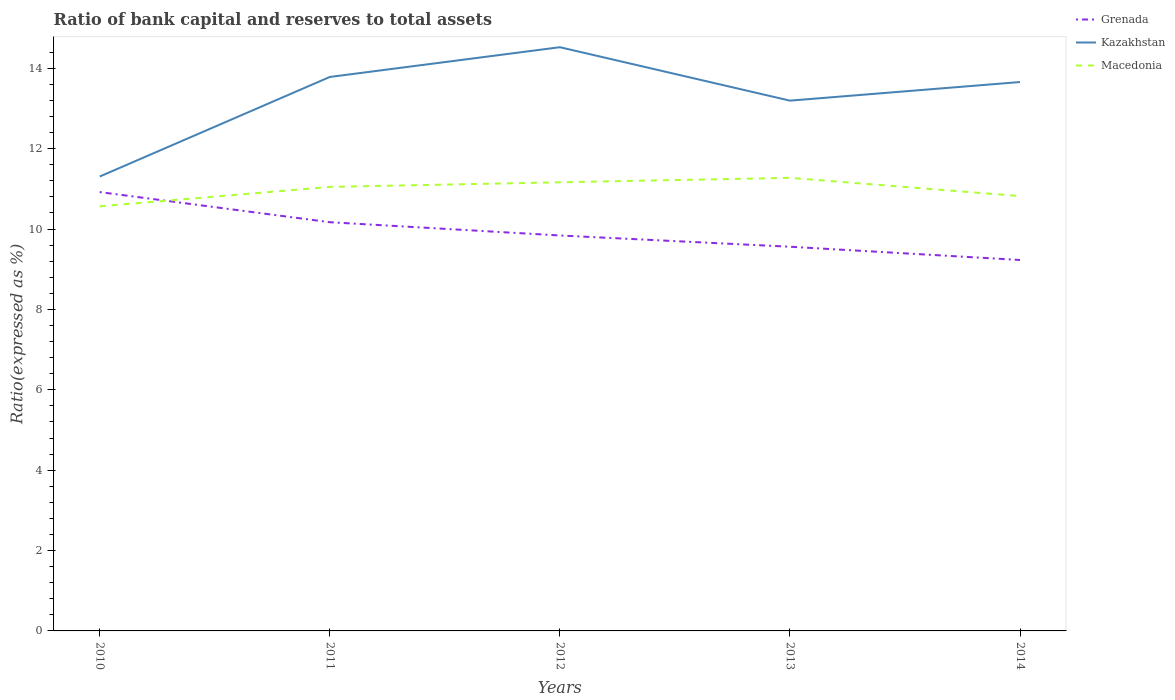How many different coloured lines are there?
Ensure brevity in your answer.  3. Does the line corresponding to Macedonia intersect with the line corresponding to Grenada?
Offer a very short reply. Yes. Is the number of lines equal to the number of legend labels?
Your answer should be very brief. Yes. Across all years, what is the maximum ratio of bank capital and reserves to total assets in Grenada?
Make the answer very short. 9.23. In which year was the ratio of bank capital and reserves to total assets in Macedonia maximum?
Offer a terse response. 2010. What is the total ratio of bank capital and reserves to total assets in Macedonia in the graph?
Offer a very short reply. 0.23. What is the difference between the highest and the second highest ratio of bank capital and reserves to total assets in Grenada?
Ensure brevity in your answer.  1.69. How many lines are there?
Your answer should be compact. 3. Does the graph contain any zero values?
Offer a terse response. No. Does the graph contain grids?
Ensure brevity in your answer.  No. What is the title of the graph?
Provide a short and direct response. Ratio of bank capital and reserves to total assets. Does "Latin America(developing only)" appear as one of the legend labels in the graph?
Give a very brief answer. No. What is the label or title of the Y-axis?
Your response must be concise. Ratio(expressed as %). What is the Ratio(expressed as %) of Grenada in 2010?
Your answer should be compact. 10.92. What is the Ratio(expressed as %) in Kazakhstan in 2010?
Provide a succinct answer. 11.31. What is the Ratio(expressed as %) of Macedonia in 2010?
Your answer should be very brief. 10.57. What is the Ratio(expressed as %) of Grenada in 2011?
Give a very brief answer. 10.17. What is the Ratio(expressed as %) of Kazakhstan in 2011?
Keep it short and to the point. 13.78. What is the Ratio(expressed as %) in Macedonia in 2011?
Give a very brief answer. 11.05. What is the Ratio(expressed as %) in Grenada in 2012?
Provide a succinct answer. 9.84. What is the Ratio(expressed as %) of Kazakhstan in 2012?
Ensure brevity in your answer.  14.52. What is the Ratio(expressed as %) in Macedonia in 2012?
Offer a terse response. 11.16. What is the Ratio(expressed as %) of Grenada in 2013?
Your response must be concise. 9.56. What is the Ratio(expressed as %) in Kazakhstan in 2013?
Offer a terse response. 13.2. What is the Ratio(expressed as %) of Macedonia in 2013?
Offer a terse response. 11.27. What is the Ratio(expressed as %) in Grenada in 2014?
Make the answer very short. 9.23. What is the Ratio(expressed as %) of Kazakhstan in 2014?
Make the answer very short. 13.66. What is the Ratio(expressed as %) of Macedonia in 2014?
Provide a short and direct response. 10.82. Across all years, what is the maximum Ratio(expressed as %) in Grenada?
Offer a terse response. 10.92. Across all years, what is the maximum Ratio(expressed as %) of Kazakhstan?
Make the answer very short. 14.52. Across all years, what is the maximum Ratio(expressed as %) in Macedonia?
Your answer should be very brief. 11.27. Across all years, what is the minimum Ratio(expressed as %) of Grenada?
Ensure brevity in your answer.  9.23. Across all years, what is the minimum Ratio(expressed as %) in Kazakhstan?
Ensure brevity in your answer.  11.31. Across all years, what is the minimum Ratio(expressed as %) in Macedonia?
Offer a terse response. 10.57. What is the total Ratio(expressed as %) in Grenada in the graph?
Your response must be concise. 49.72. What is the total Ratio(expressed as %) of Kazakhstan in the graph?
Your answer should be compact. 66.47. What is the total Ratio(expressed as %) in Macedonia in the graph?
Provide a short and direct response. 54.87. What is the difference between the Ratio(expressed as %) of Grenada in 2010 and that in 2011?
Provide a succinct answer. 0.75. What is the difference between the Ratio(expressed as %) in Kazakhstan in 2010 and that in 2011?
Give a very brief answer. -2.48. What is the difference between the Ratio(expressed as %) of Macedonia in 2010 and that in 2011?
Offer a terse response. -0.48. What is the difference between the Ratio(expressed as %) in Kazakhstan in 2010 and that in 2012?
Your answer should be compact. -3.22. What is the difference between the Ratio(expressed as %) of Macedonia in 2010 and that in 2012?
Ensure brevity in your answer.  -0.6. What is the difference between the Ratio(expressed as %) in Grenada in 2010 and that in 2013?
Your response must be concise. 1.36. What is the difference between the Ratio(expressed as %) in Kazakhstan in 2010 and that in 2013?
Make the answer very short. -1.89. What is the difference between the Ratio(expressed as %) of Macedonia in 2010 and that in 2013?
Your answer should be compact. -0.71. What is the difference between the Ratio(expressed as %) of Grenada in 2010 and that in 2014?
Provide a short and direct response. 1.69. What is the difference between the Ratio(expressed as %) in Kazakhstan in 2010 and that in 2014?
Give a very brief answer. -2.35. What is the difference between the Ratio(expressed as %) in Macedonia in 2010 and that in 2014?
Your answer should be very brief. -0.25. What is the difference between the Ratio(expressed as %) in Grenada in 2011 and that in 2012?
Provide a succinct answer. 0.33. What is the difference between the Ratio(expressed as %) of Kazakhstan in 2011 and that in 2012?
Ensure brevity in your answer.  -0.74. What is the difference between the Ratio(expressed as %) in Macedonia in 2011 and that in 2012?
Ensure brevity in your answer.  -0.12. What is the difference between the Ratio(expressed as %) of Grenada in 2011 and that in 2013?
Provide a succinct answer. 0.61. What is the difference between the Ratio(expressed as %) of Kazakhstan in 2011 and that in 2013?
Your answer should be compact. 0.59. What is the difference between the Ratio(expressed as %) in Macedonia in 2011 and that in 2013?
Your answer should be very brief. -0.23. What is the difference between the Ratio(expressed as %) of Grenada in 2011 and that in 2014?
Your answer should be compact. 0.94. What is the difference between the Ratio(expressed as %) in Kazakhstan in 2011 and that in 2014?
Ensure brevity in your answer.  0.13. What is the difference between the Ratio(expressed as %) of Macedonia in 2011 and that in 2014?
Make the answer very short. 0.23. What is the difference between the Ratio(expressed as %) in Grenada in 2012 and that in 2013?
Offer a terse response. 0.28. What is the difference between the Ratio(expressed as %) of Kazakhstan in 2012 and that in 2013?
Provide a succinct answer. 1.33. What is the difference between the Ratio(expressed as %) of Macedonia in 2012 and that in 2013?
Offer a terse response. -0.11. What is the difference between the Ratio(expressed as %) of Grenada in 2012 and that in 2014?
Your answer should be very brief. 0.61. What is the difference between the Ratio(expressed as %) of Kazakhstan in 2012 and that in 2014?
Your answer should be compact. 0.87. What is the difference between the Ratio(expressed as %) in Macedonia in 2012 and that in 2014?
Your answer should be very brief. 0.34. What is the difference between the Ratio(expressed as %) in Grenada in 2013 and that in 2014?
Offer a very short reply. 0.33. What is the difference between the Ratio(expressed as %) in Kazakhstan in 2013 and that in 2014?
Offer a very short reply. -0.46. What is the difference between the Ratio(expressed as %) in Macedonia in 2013 and that in 2014?
Provide a short and direct response. 0.45. What is the difference between the Ratio(expressed as %) in Grenada in 2010 and the Ratio(expressed as %) in Kazakhstan in 2011?
Provide a succinct answer. -2.86. What is the difference between the Ratio(expressed as %) in Grenada in 2010 and the Ratio(expressed as %) in Macedonia in 2011?
Provide a succinct answer. -0.13. What is the difference between the Ratio(expressed as %) in Kazakhstan in 2010 and the Ratio(expressed as %) in Macedonia in 2011?
Provide a short and direct response. 0.26. What is the difference between the Ratio(expressed as %) in Grenada in 2010 and the Ratio(expressed as %) in Kazakhstan in 2012?
Provide a short and direct response. -3.6. What is the difference between the Ratio(expressed as %) in Grenada in 2010 and the Ratio(expressed as %) in Macedonia in 2012?
Provide a succinct answer. -0.24. What is the difference between the Ratio(expressed as %) of Kazakhstan in 2010 and the Ratio(expressed as %) of Macedonia in 2012?
Offer a terse response. 0.14. What is the difference between the Ratio(expressed as %) in Grenada in 2010 and the Ratio(expressed as %) in Kazakhstan in 2013?
Provide a succinct answer. -2.28. What is the difference between the Ratio(expressed as %) of Grenada in 2010 and the Ratio(expressed as %) of Macedonia in 2013?
Your answer should be very brief. -0.35. What is the difference between the Ratio(expressed as %) of Kazakhstan in 2010 and the Ratio(expressed as %) of Macedonia in 2013?
Offer a very short reply. 0.03. What is the difference between the Ratio(expressed as %) of Grenada in 2010 and the Ratio(expressed as %) of Kazakhstan in 2014?
Your answer should be very brief. -2.74. What is the difference between the Ratio(expressed as %) of Grenada in 2010 and the Ratio(expressed as %) of Macedonia in 2014?
Your response must be concise. 0.1. What is the difference between the Ratio(expressed as %) of Kazakhstan in 2010 and the Ratio(expressed as %) of Macedonia in 2014?
Offer a terse response. 0.49. What is the difference between the Ratio(expressed as %) of Grenada in 2011 and the Ratio(expressed as %) of Kazakhstan in 2012?
Offer a very short reply. -4.35. What is the difference between the Ratio(expressed as %) in Grenada in 2011 and the Ratio(expressed as %) in Macedonia in 2012?
Offer a terse response. -0.99. What is the difference between the Ratio(expressed as %) of Kazakhstan in 2011 and the Ratio(expressed as %) of Macedonia in 2012?
Provide a short and direct response. 2.62. What is the difference between the Ratio(expressed as %) in Grenada in 2011 and the Ratio(expressed as %) in Kazakhstan in 2013?
Offer a very short reply. -3.03. What is the difference between the Ratio(expressed as %) of Grenada in 2011 and the Ratio(expressed as %) of Macedonia in 2013?
Provide a short and direct response. -1.1. What is the difference between the Ratio(expressed as %) of Kazakhstan in 2011 and the Ratio(expressed as %) of Macedonia in 2013?
Give a very brief answer. 2.51. What is the difference between the Ratio(expressed as %) in Grenada in 2011 and the Ratio(expressed as %) in Kazakhstan in 2014?
Offer a very short reply. -3.49. What is the difference between the Ratio(expressed as %) of Grenada in 2011 and the Ratio(expressed as %) of Macedonia in 2014?
Provide a short and direct response. -0.65. What is the difference between the Ratio(expressed as %) in Kazakhstan in 2011 and the Ratio(expressed as %) in Macedonia in 2014?
Your answer should be compact. 2.96. What is the difference between the Ratio(expressed as %) of Grenada in 2012 and the Ratio(expressed as %) of Kazakhstan in 2013?
Offer a terse response. -3.36. What is the difference between the Ratio(expressed as %) of Grenada in 2012 and the Ratio(expressed as %) of Macedonia in 2013?
Keep it short and to the point. -1.43. What is the difference between the Ratio(expressed as %) of Kazakhstan in 2012 and the Ratio(expressed as %) of Macedonia in 2013?
Your answer should be compact. 3.25. What is the difference between the Ratio(expressed as %) of Grenada in 2012 and the Ratio(expressed as %) of Kazakhstan in 2014?
Your answer should be compact. -3.82. What is the difference between the Ratio(expressed as %) in Grenada in 2012 and the Ratio(expressed as %) in Macedonia in 2014?
Offer a very short reply. -0.98. What is the difference between the Ratio(expressed as %) of Kazakhstan in 2012 and the Ratio(expressed as %) of Macedonia in 2014?
Provide a short and direct response. 3.7. What is the difference between the Ratio(expressed as %) of Grenada in 2013 and the Ratio(expressed as %) of Kazakhstan in 2014?
Provide a short and direct response. -4.1. What is the difference between the Ratio(expressed as %) of Grenada in 2013 and the Ratio(expressed as %) of Macedonia in 2014?
Ensure brevity in your answer.  -1.26. What is the difference between the Ratio(expressed as %) of Kazakhstan in 2013 and the Ratio(expressed as %) of Macedonia in 2014?
Provide a short and direct response. 2.38. What is the average Ratio(expressed as %) of Grenada per year?
Your response must be concise. 9.94. What is the average Ratio(expressed as %) of Kazakhstan per year?
Your answer should be very brief. 13.29. What is the average Ratio(expressed as %) in Macedonia per year?
Give a very brief answer. 10.97. In the year 2010, what is the difference between the Ratio(expressed as %) in Grenada and Ratio(expressed as %) in Kazakhstan?
Keep it short and to the point. -0.39. In the year 2010, what is the difference between the Ratio(expressed as %) in Grenada and Ratio(expressed as %) in Macedonia?
Offer a terse response. 0.35. In the year 2010, what is the difference between the Ratio(expressed as %) in Kazakhstan and Ratio(expressed as %) in Macedonia?
Provide a succinct answer. 0.74. In the year 2011, what is the difference between the Ratio(expressed as %) in Grenada and Ratio(expressed as %) in Kazakhstan?
Ensure brevity in your answer.  -3.61. In the year 2011, what is the difference between the Ratio(expressed as %) in Grenada and Ratio(expressed as %) in Macedonia?
Offer a terse response. -0.88. In the year 2011, what is the difference between the Ratio(expressed as %) of Kazakhstan and Ratio(expressed as %) of Macedonia?
Ensure brevity in your answer.  2.74. In the year 2012, what is the difference between the Ratio(expressed as %) of Grenada and Ratio(expressed as %) of Kazakhstan?
Your answer should be compact. -4.68. In the year 2012, what is the difference between the Ratio(expressed as %) in Grenada and Ratio(expressed as %) in Macedonia?
Keep it short and to the point. -1.32. In the year 2012, what is the difference between the Ratio(expressed as %) of Kazakhstan and Ratio(expressed as %) of Macedonia?
Your response must be concise. 3.36. In the year 2013, what is the difference between the Ratio(expressed as %) in Grenada and Ratio(expressed as %) in Kazakhstan?
Give a very brief answer. -3.64. In the year 2013, what is the difference between the Ratio(expressed as %) of Grenada and Ratio(expressed as %) of Macedonia?
Your answer should be very brief. -1.71. In the year 2013, what is the difference between the Ratio(expressed as %) in Kazakhstan and Ratio(expressed as %) in Macedonia?
Offer a terse response. 1.92. In the year 2014, what is the difference between the Ratio(expressed as %) of Grenada and Ratio(expressed as %) of Kazakhstan?
Your answer should be very brief. -4.43. In the year 2014, what is the difference between the Ratio(expressed as %) of Grenada and Ratio(expressed as %) of Macedonia?
Provide a succinct answer. -1.59. In the year 2014, what is the difference between the Ratio(expressed as %) in Kazakhstan and Ratio(expressed as %) in Macedonia?
Offer a very short reply. 2.84. What is the ratio of the Ratio(expressed as %) in Grenada in 2010 to that in 2011?
Ensure brevity in your answer.  1.07. What is the ratio of the Ratio(expressed as %) of Kazakhstan in 2010 to that in 2011?
Make the answer very short. 0.82. What is the ratio of the Ratio(expressed as %) of Macedonia in 2010 to that in 2011?
Make the answer very short. 0.96. What is the ratio of the Ratio(expressed as %) in Grenada in 2010 to that in 2012?
Provide a short and direct response. 1.11. What is the ratio of the Ratio(expressed as %) of Kazakhstan in 2010 to that in 2012?
Keep it short and to the point. 0.78. What is the ratio of the Ratio(expressed as %) in Macedonia in 2010 to that in 2012?
Make the answer very short. 0.95. What is the ratio of the Ratio(expressed as %) in Grenada in 2010 to that in 2013?
Provide a short and direct response. 1.14. What is the ratio of the Ratio(expressed as %) of Kazakhstan in 2010 to that in 2013?
Your answer should be very brief. 0.86. What is the ratio of the Ratio(expressed as %) of Macedonia in 2010 to that in 2013?
Provide a short and direct response. 0.94. What is the ratio of the Ratio(expressed as %) of Grenada in 2010 to that in 2014?
Give a very brief answer. 1.18. What is the ratio of the Ratio(expressed as %) in Kazakhstan in 2010 to that in 2014?
Your answer should be very brief. 0.83. What is the ratio of the Ratio(expressed as %) in Macedonia in 2010 to that in 2014?
Offer a terse response. 0.98. What is the ratio of the Ratio(expressed as %) of Grenada in 2011 to that in 2012?
Provide a short and direct response. 1.03. What is the ratio of the Ratio(expressed as %) of Kazakhstan in 2011 to that in 2012?
Your response must be concise. 0.95. What is the ratio of the Ratio(expressed as %) in Macedonia in 2011 to that in 2012?
Provide a short and direct response. 0.99. What is the ratio of the Ratio(expressed as %) in Grenada in 2011 to that in 2013?
Your response must be concise. 1.06. What is the ratio of the Ratio(expressed as %) in Kazakhstan in 2011 to that in 2013?
Your answer should be very brief. 1.04. What is the ratio of the Ratio(expressed as %) of Grenada in 2011 to that in 2014?
Make the answer very short. 1.1. What is the ratio of the Ratio(expressed as %) of Kazakhstan in 2011 to that in 2014?
Ensure brevity in your answer.  1.01. What is the ratio of the Ratio(expressed as %) of Macedonia in 2011 to that in 2014?
Your answer should be compact. 1.02. What is the ratio of the Ratio(expressed as %) in Grenada in 2012 to that in 2013?
Your answer should be very brief. 1.03. What is the ratio of the Ratio(expressed as %) in Kazakhstan in 2012 to that in 2013?
Make the answer very short. 1.1. What is the ratio of the Ratio(expressed as %) in Macedonia in 2012 to that in 2013?
Your answer should be compact. 0.99. What is the ratio of the Ratio(expressed as %) of Grenada in 2012 to that in 2014?
Keep it short and to the point. 1.07. What is the ratio of the Ratio(expressed as %) in Kazakhstan in 2012 to that in 2014?
Provide a succinct answer. 1.06. What is the ratio of the Ratio(expressed as %) of Macedonia in 2012 to that in 2014?
Your response must be concise. 1.03. What is the ratio of the Ratio(expressed as %) of Grenada in 2013 to that in 2014?
Provide a succinct answer. 1.04. What is the ratio of the Ratio(expressed as %) in Kazakhstan in 2013 to that in 2014?
Ensure brevity in your answer.  0.97. What is the ratio of the Ratio(expressed as %) in Macedonia in 2013 to that in 2014?
Ensure brevity in your answer.  1.04. What is the difference between the highest and the second highest Ratio(expressed as %) of Grenada?
Offer a terse response. 0.75. What is the difference between the highest and the second highest Ratio(expressed as %) in Kazakhstan?
Offer a very short reply. 0.74. What is the difference between the highest and the second highest Ratio(expressed as %) in Macedonia?
Your response must be concise. 0.11. What is the difference between the highest and the lowest Ratio(expressed as %) of Grenada?
Offer a very short reply. 1.69. What is the difference between the highest and the lowest Ratio(expressed as %) of Kazakhstan?
Your response must be concise. 3.22. What is the difference between the highest and the lowest Ratio(expressed as %) of Macedonia?
Give a very brief answer. 0.71. 